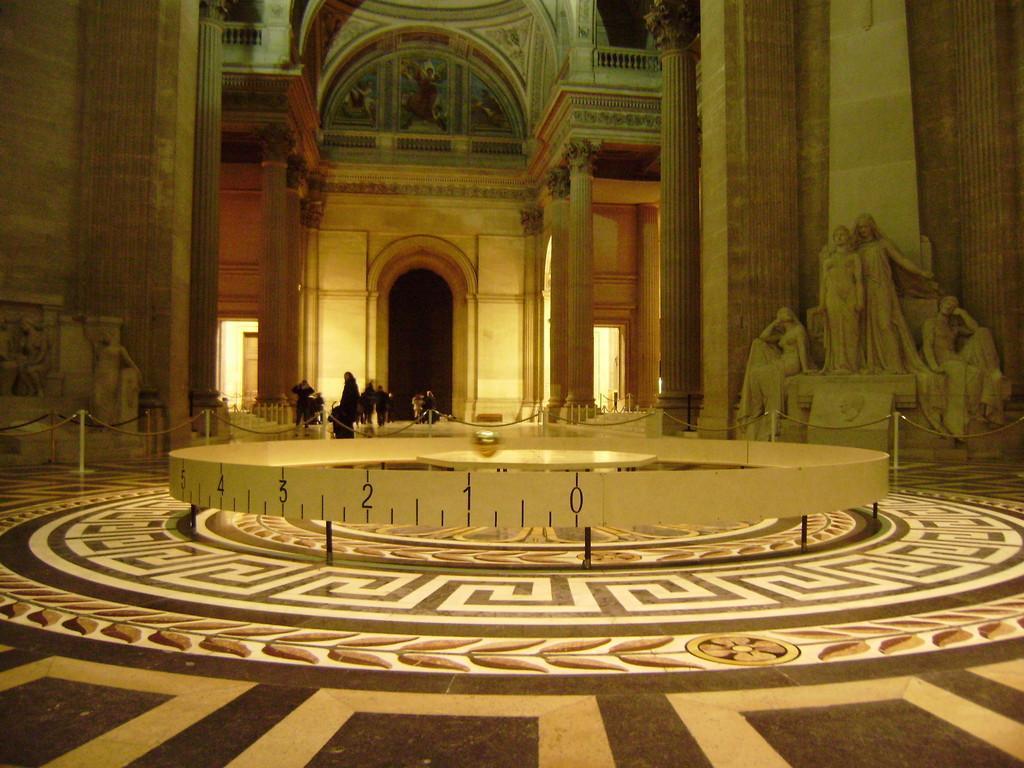Please provide a concise description of this image. In the foreground of the picture there is railing like object. In the center there is table like object. In foreground we can see tiles. On the right there is sculpture. On the left that is sculpture. In the center of the background there are people. At the top there are pictures on the roof. In the background there are pillars. 